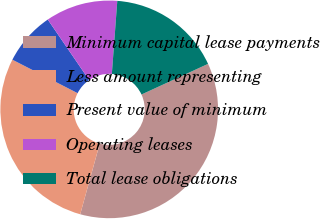Convert chart to OTSL. <chart><loc_0><loc_0><loc_500><loc_500><pie_chart><fcel>Minimum capital lease payments<fcel>Less amount representing<fcel>Present value of minimum<fcel>Operating leases<fcel>Total lease obligations<nl><fcel>36.16%<fcel>28.25%<fcel>7.91%<fcel>10.73%<fcel>16.95%<nl></chart> 